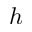Convert formula to latex. <formula><loc_0><loc_0><loc_500><loc_500>h</formula> 